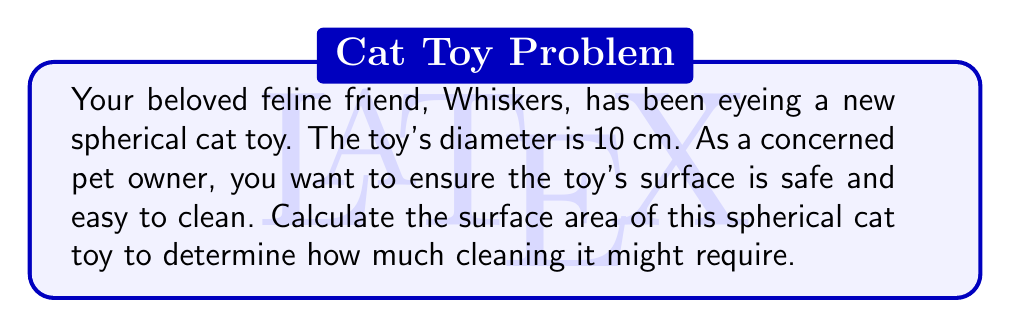What is the answer to this math problem? To solve this problem, we'll follow these steps:

1. Identify the given information:
   - The toy is spherical
   - The diameter is 10 cm

2. Recall the formula for the surface area of a sphere:
   $$A = 4\pi r^2$$
   where $A$ is the surface area and $r$ is the radius of the sphere.

3. Calculate the radius:
   The diameter is 10 cm, so the radius is half of that:
   $$r = \frac{10}{2} = 5 \text{ cm}$$

4. Substitute the radius into the surface area formula:
   $$A = 4\pi (5 \text{ cm})^2$$

5. Simplify:
   $$A = 4\pi (25 \text{ cm}^2) = 100\pi \text{ cm}^2$$

6. Calculate the final result:
   $$A \approx 314.16 \text{ cm}^2$$

[asy]
import geometry;

size(100);
draw(circle((0,0),5));
draw((0,0)--(5,0),Arrow);
label("5 cm", (2.5,0.5), N);
label("10 cm", (-5,-5.5), S);
draw((-5,0)--(5,0), dashed);
[/asy]
Answer: The surface area of the spherical cat toy is $100\pi \text{ cm}^2$ or approximately $314.16 \text{ cm}^2$. 